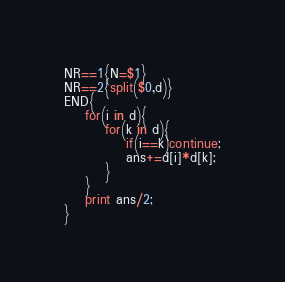Convert code to text. <code><loc_0><loc_0><loc_500><loc_500><_Awk_>NR==1{N=$1}
NR==2{split($0,d)}
END{
	for(i in d){
    	for(k in d){
        	if(i==k)continue;
        	ans+=d[i]*d[k];
        }
    }
    print ans/2;
}</code> 